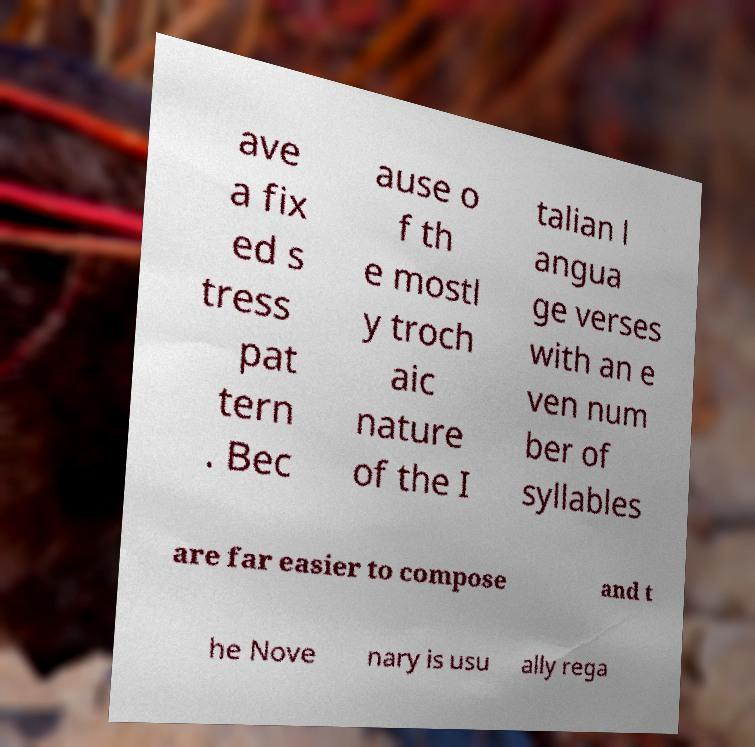What messages or text are displayed in this image? I need them in a readable, typed format. ave a fix ed s tress pat tern . Bec ause o f th e mostl y troch aic nature of the I talian l angua ge verses with an e ven num ber of syllables are far easier to compose and t he Nove nary is usu ally rega 